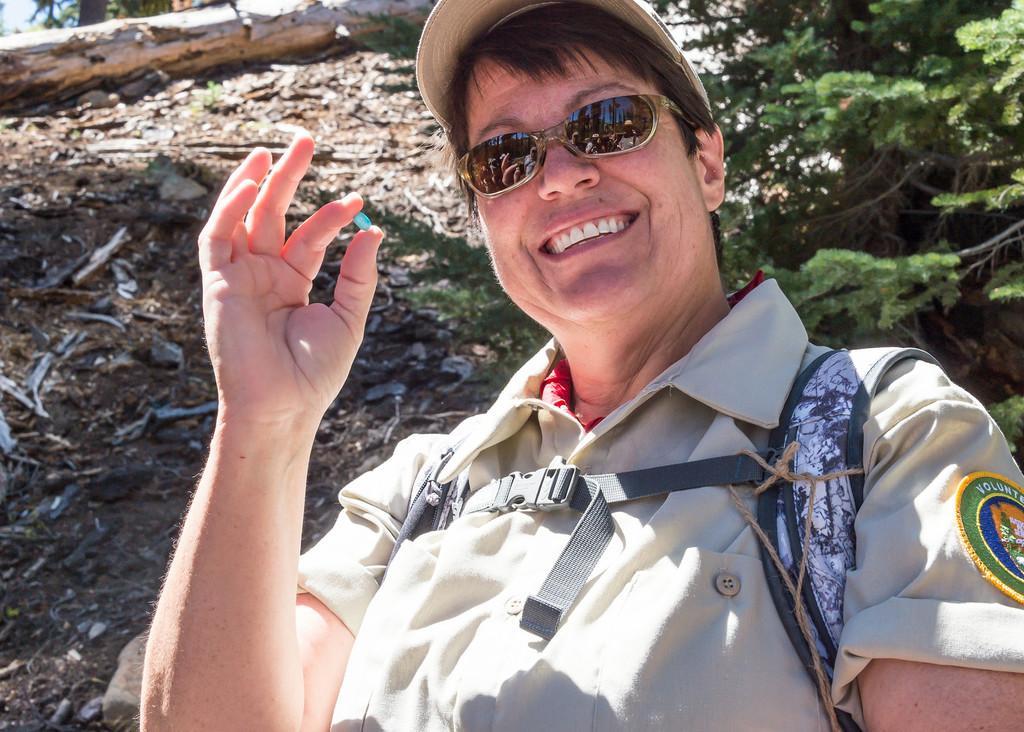In one or two sentences, can you explain what this image depicts? In this image I can see a person and the person is wearing uniform and holding some object which is in green color, background I can see trees in green color and the sky is in white color. 